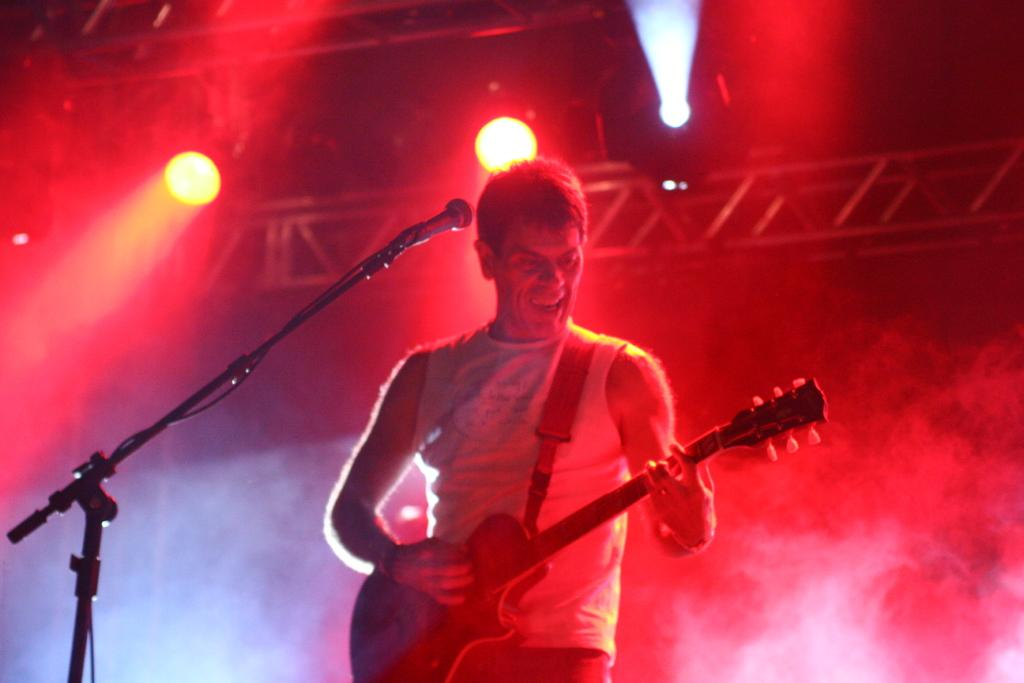What is the man in the image holding? The man is holding a musical instrument. What is placed in front of the man? A microphone is placed in front of the man. What can be seen in the background of the image? There are electric lights and an iron grill in the background of the image. What type of crown is the man wearing in the image? There is no crown present in the image; the man is holding a musical instrument and standing in front of a microphone. What advertisement can be seen on the iron grill in the image? There is no advertisement visible on the iron grill in the image; it is simply a background element. 